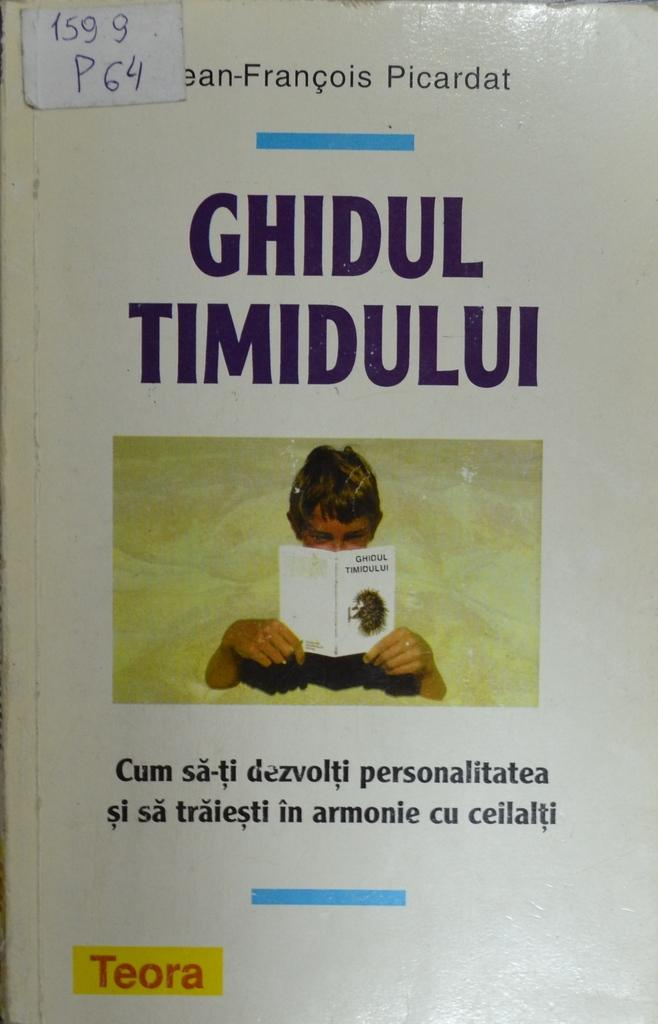<image>
Summarize the visual content of the image. the cover of book Ghidul Timidului by Picardat 